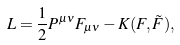<formula> <loc_0><loc_0><loc_500><loc_500>L = \frac { 1 } { 2 } P ^ { \mu \nu } F _ { \mu \nu } - K ( F , \tilde { F } ) ,</formula> 